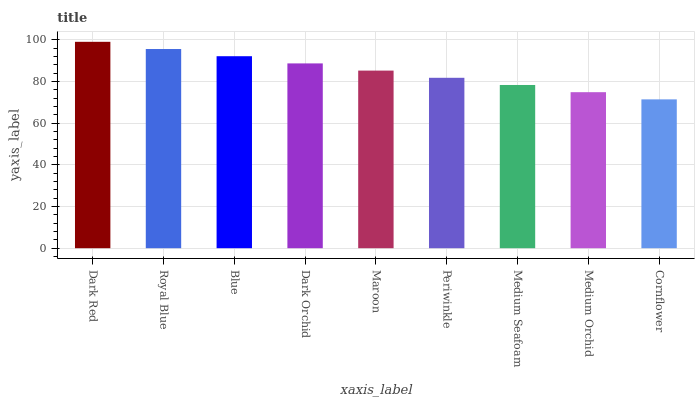Is Cornflower the minimum?
Answer yes or no. Yes. Is Dark Red the maximum?
Answer yes or no. Yes. Is Royal Blue the minimum?
Answer yes or no. No. Is Royal Blue the maximum?
Answer yes or no. No. Is Dark Red greater than Royal Blue?
Answer yes or no. Yes. Is Royal Blue less than Dark Red?
Answer yes or no. Yes. Is Royal Blue greater than Dark Red?
Answer yes or no. No. Is Dark Red less than Royal Blue?
Answer yes or no. No. Is Maroon the high median?
Answer yes or no. Yes. Is Maroon the low median?
Answer yes or no. Yes. Is Dark Red the high median?
Answer yes or no. No. Is Medium Seafoam the low median?
Answer yes or no. No. 